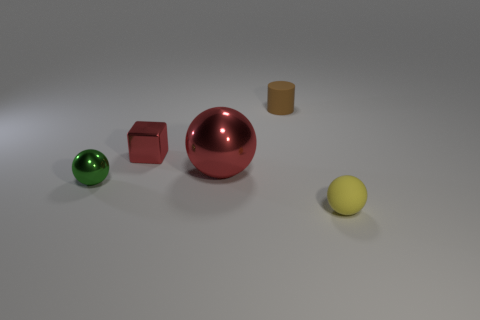Add 5 green objects. How many objects exist? 10 Subtract all cylinders. How many objects are left? 4 Add 5 red spheres. How many red spheres exist? 6 Subtract 0 gray balls. How many objects are left? 5 Subtract all tiny red matte balls. Subtract all small red things. How many objects are left? 4 Add 5 red metallic objects. How many red metallic objects are left? 7 